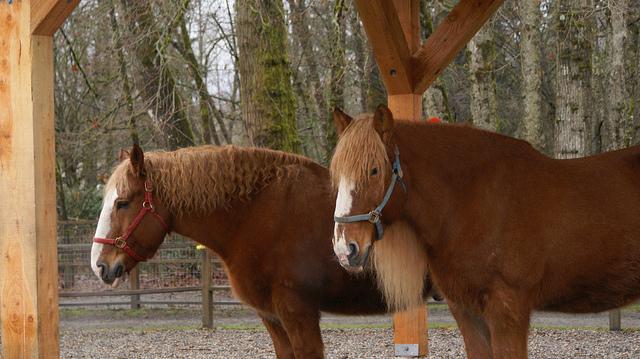Are these horses inside or outside?
Short answer required. Outside. Are the horses twins?
Answer briefly. No. What color are the horses?
Answer briefly. Brown. What are these animals wearing?
Concise answer only. Nothing. 